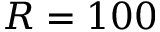Convert formula to latex. <formula><loc_0><loc_0><loc_500><loc_500>R = 1 0 0</formula> 